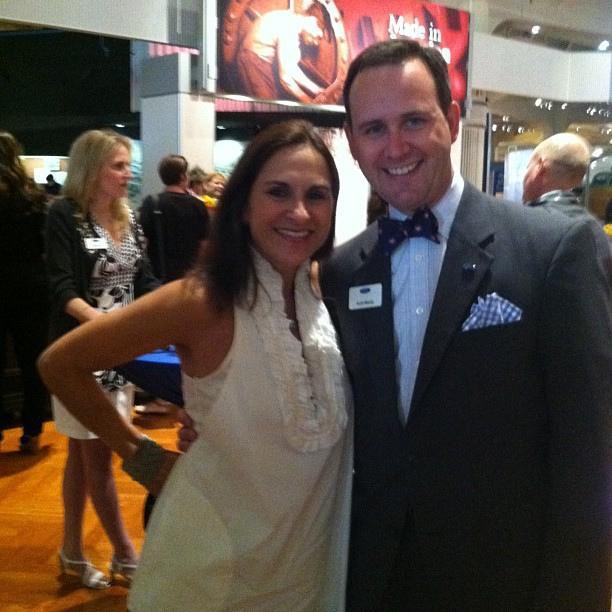How many people are in the picture?
Give a very brief answer. 6. How many donuts are there?
Give a very brief answer. 0. 